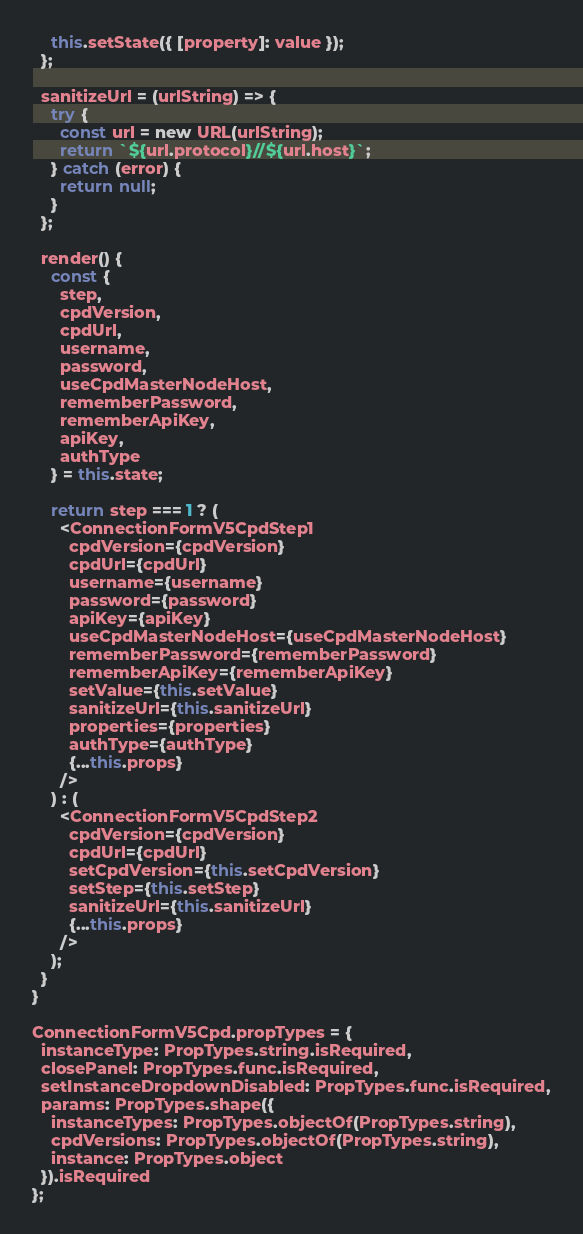Convert code to text. <code><loc_0><loc_0><loc_500><loc_500><_JavaScript_>    this.setState({ [property]: value });
  };

  sanitizeUrl = (urlString) => {
    try {
      const url = new URL(urlString);
      return `${url.protocol}//${url.host}`;
    } catch (error) {
      return null;
    }
  };

  render() {
    const {
      step,
      cpdVersion,
      cpdUrl,
      username,
      password,
      useCpdMasterNodeHost,
      rememberPassword,
      rememberApiKey,
      apiKey,
      authType
    } = this.state;

    return step === 1 ? (
      <ConnectionFormV5CpdStep1
        cpdVersion={cpdVersion}
        cpdUrl={cpdUrl}
        username={username}
        password={password}
        apiKey={apiKey}
        useCpdMasterNodeHost={useCpdMasterNodeHost}
        rememberPassword={rememberPassword}
        rememberApiKey={rememberApiKey}
        setValue={this.setValue}
        sanitizeUrl={this.sanitizeUrl}
        properties={properties}
        authType={authType}
        {...this.props}
      />
    ) : (
      <ConnectionFormV5CpdStep2
        cpdVersion={cpdVersion}
        cpdUrl={cpdUrl}
        setCpdVersion={this.setCpdVersion}
        setStep={this.setStep}
        sanitizeUrl={this.sanitizeUrl}
        {...this.props}
      />
    );
  }
}

ConnectionFormV5Cpd.propTypes = {
  instanceType: PropTypes.string.isRequired,
  closePanel: PropTypes.func.isRequired,
  setInstanceDropdownDisabled: PropTypes.func.isRequired,
  params: PropTypes.shape({
    instanceTypes: PropTypes.objectOf(PropTypes.string),
    cpdVersions: PropTypes.objectOf(PropTypes.string),
    instance: PropTypes.object
  }).isRequired
};
</code> 